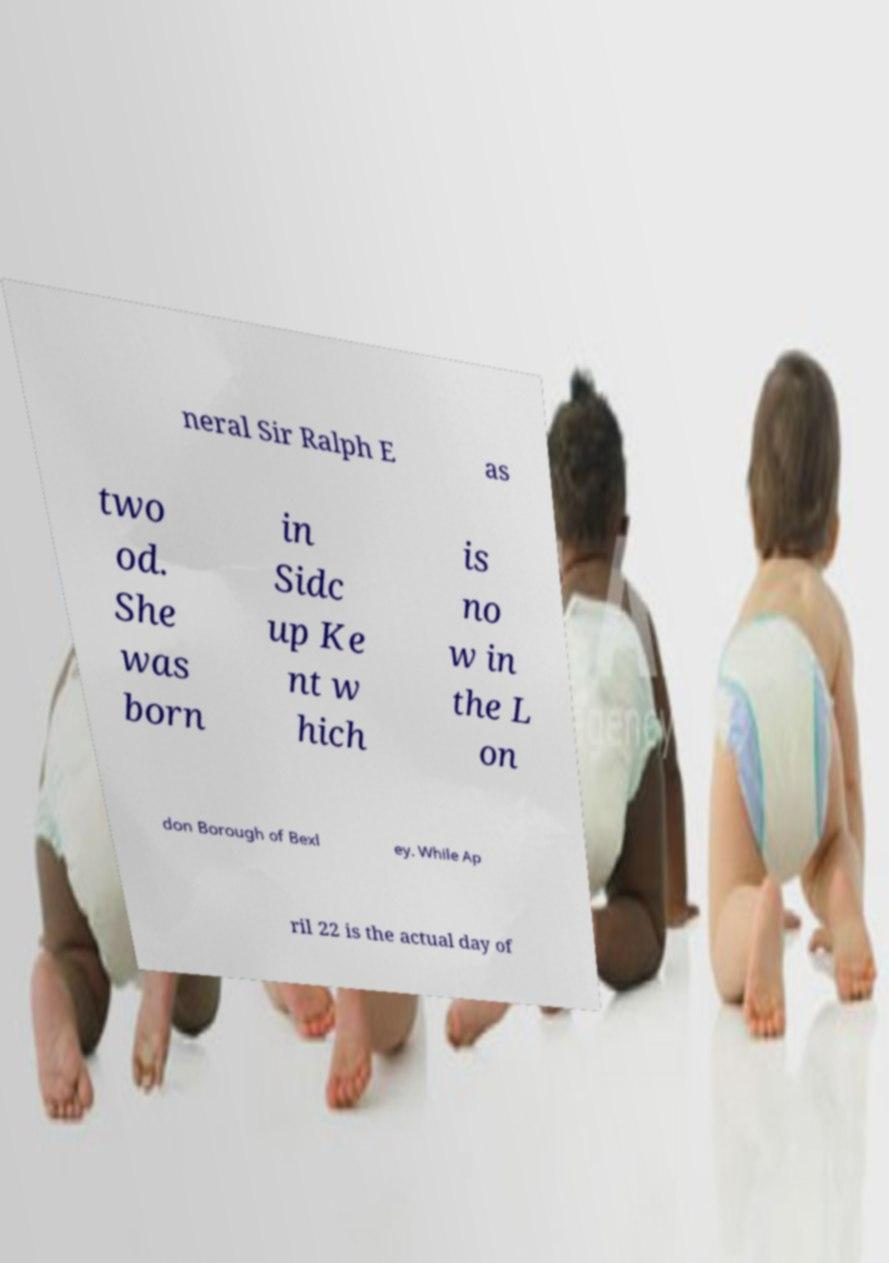Can you read and provide the text displayed in the image?This photo seems to have some interesting text. Can you extract and type it out for me? neral Sir Ralph E as two od. She was born in Sidc up Ke nt w hich is no w in the L on don Borough of Bexl ey. While Ap ril 22 is the actual day of 